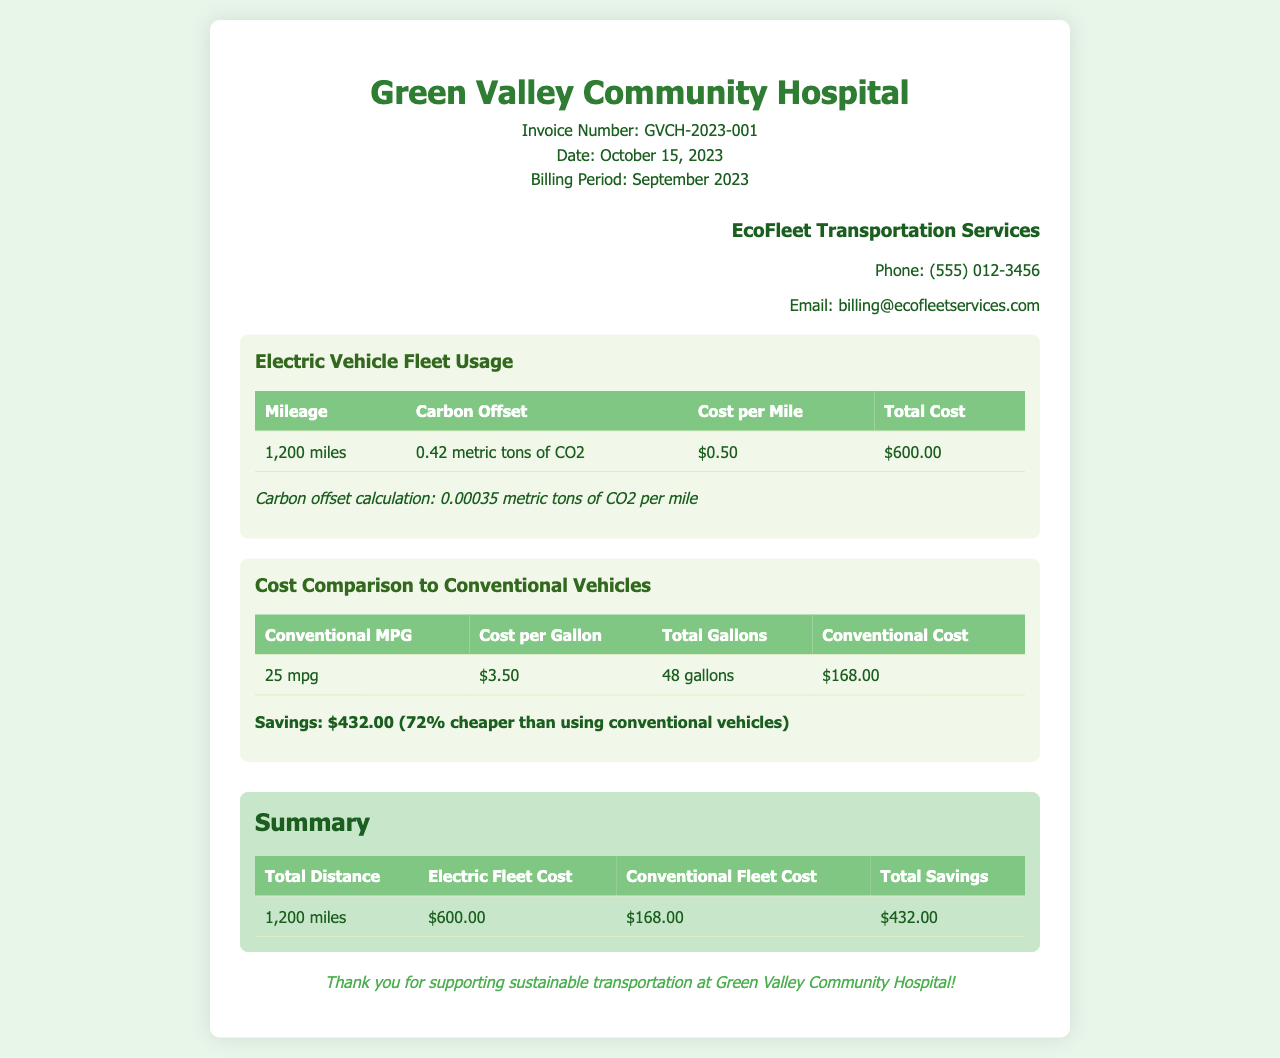What is the invoice number? The invoice number is listed in the header section of the document.
Answer: GVCH-2023-001 What is the total mileage for the electric vehicle fleet usage? The total mileage can be found in the details section under "Electric Vehicle Fleet Usage".
Answer: 1,200 miles What is the cost per mile for electric vehicle usage? The cost per mile is specified in the "Electric Vehicle Fleet Usage" table.
Answer: $0.50 What is the carbon offset for the mileage used? The carbon offset amount is available in the "Electric Vehicle Fleet Usage" section of the document.
Answer: 0.42 metric tons of CO2 How much did the conventional vehicles cost for the same distance? The cost for conventional vehicles is detailed in the "Cost Comparison to Conventional Vehicles" section.
Answer: $168.00 What is the total savings by using the electric vehicle fleet? The total savings are summarized in the “Summary” section of the invoice.
Answer: $432.00 What is the date of the invoice? The date of the invoice is indicated in the header section.
Answer: October 15, 2023 What is the conventional MPG mentioned in the comparison? The conventional MPG can be found in the "Cost Comparison to Conventional Vehicles" section.
Answer: 25 mpg What is the billing period for this invoice? The billing period is stated in the header under "Billing Period".
Answer: September 2023 